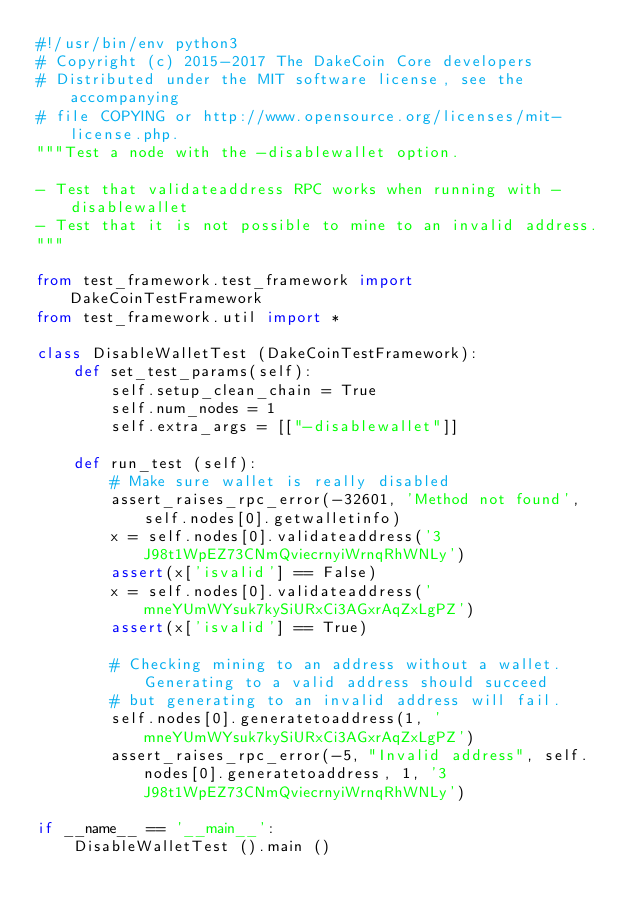Convert code to text. <code><loc_0><loc_0><loc_500><loc_500><_Python_>#!/usr/bin/env python3
# Copyright (c) 2015-2017 The DakeCoin Core developers
# Distributed under the MIT software license, see the accompanying
# file COPYING or http://www.opensource.org/licenses/mit-license.php.
"""Test a node with the -disablewallet option.

- Test that validateaddress RPC works when running with -disablewallet
- Test that it is not possible to mine to an invalid address.
"""

from test_framework.test_framework import DakeCoinTestFramework
from test_framework.util import *

class DisableWalletTest (DakeCoinTestFramework):
    def set_test_params(self):
        self.setup_clean_chain = True
        self.num_nodes = 1
        self.extra_args = [["-disablewallet"]]

    def run_test (self):
        # Make sure wallet is really disabled
        assert_raises_rpc_error(-32601, 'Method not found', self.nodes[0].getwalletinfo)
        x = self.nodes[0].validateaddress('3J98t1WpEZ73CNmQviecrnyiWrnqRhWNLy')
        assert(x['isvalid'] == False)
        x = self.nodes[0].validateaddress('mneYUmWYsuk7kySiURxCi3AGxrAqZxLgPZ')
        assert(x['isvalid'] == True)

        # Checking mining to an address without a wallet. Generating to a valid address should succeed
        # but generating to an invalid address will fail.
        self.nodes[0].generatetoaddress(1, 'mneYUmWYsuk7kySiURxCi3AGxrAqZxLgPZ')
        assert_raises_rpc_error(-5, "Invalid address", self.nodes[0].generatetoaddress, 1, '3J98t1WpEZ73CNmQviecrnyiWrnqRhWNLy')

if __name__ == '__main__':
    DisableWalletTest ().main ()
</code> 